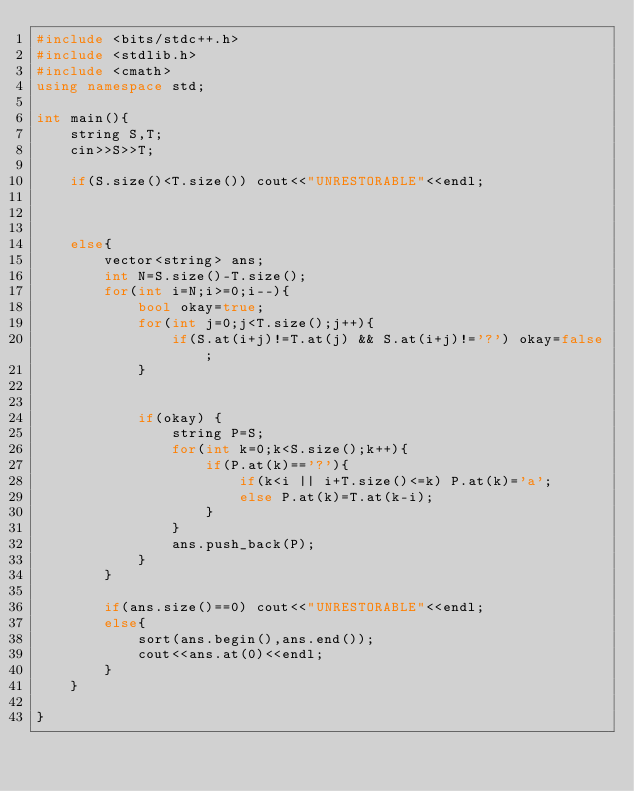<code> <loc_0><loc_0><loc_500><loc_500><_C++_>#include <bits/stdc++.h>
#include <stdlib.h>
#include <cmath>
using namespace std;

int main(){
    string S,T;
    cin>>S>>T;

    if(S.size()<T.size()) cout<<"UNRESTORABLE"<<endl;

    

    else{
        vector<string> ans;
        int N=S.size()-T.size();
        for(int i=N;i>=0;i--){
            bool okay=true;
            for(int j=0;j<T.size();j++){
                if(S.at(i+j)!=T.at(j) && S.at(i+j)!='?') okay=false;
            }

            
            if(okay) {
                string P=S;
                for(int k=0;k<S.size();k++){
                    if(P.at(k)=='?'){
                        if(k<i || i+T.size()<=k) P.at(k)='a';
                        else P.at(k)=T.at(k-i);
                    }
                }
                ans.push_back(P);
            }
        }

        if(ans.size()==0) cout<<"UNRESTORABLE"<<endl;
        else{
            sort(ans.begin(),ans.end());
            cout<<ans.at(0)<<endl;
        }
    }

}</code> 